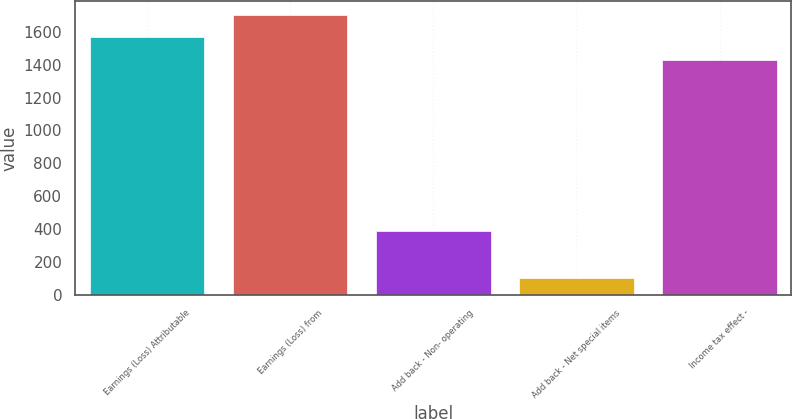<chart> <loc_0><loc_0><loc_500><loc_500><bar_chart><fcel>Earnings (Loss) Attributable<fcel>Earnings (Loss) from<fcel>Add back - Non- operating<fcel>Add back - Net special items<fcel>Income tax effect -<nl><fcel>1566.2<fcel>1702.4<fcel>386<fcel>106<fcel>1430<nl></chart> 